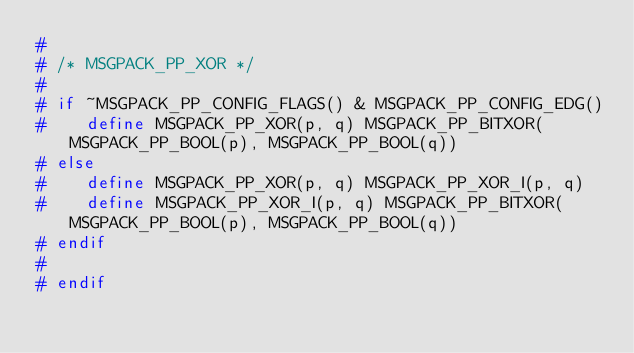Convert code to text. <code><loc_0><loc_0><loc_500><loc_500><_C++_>#
# /* MSGPACK_PP_XOR */
#
# if ~MSGPACK_PP_CONFIG_FLAGS() & MSGPACK_PP_CONFIG_EDG()
#    define MSGPACK_PP_XOR(p, q) MSGPACK_PP_BITXOR(MSGPACK_PP_BOOL(p), MSGPACK_PP_BOOL(q))
# else
#    define MSGPACK_PP_XOR(p, q) MSGPACK_PP_XOR_I(p, q)
#    define MSGPACK_PP_XOR_I(p, q) MSGPACK_PP_BITXOR(MSGPACK_PP_BOOL(p), MSGPACK_PP_BOOL(q))
# endif
#
# endif
</code> 